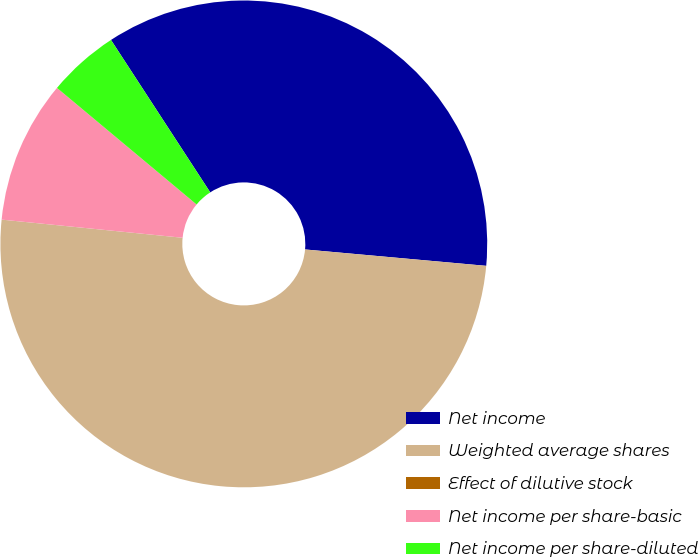Convert chart to OTSL. <chart><loc_0><loc_0><loc_500><loc_500><pie_chart><fcel>Net income<fcel>Weighted average shares<fcel>Effect of dilutive stock<fcel>Net income per share-basic<fcel>Net income per share-diluted<nl><fcel>35.62%<fcel>50.15%<fcel>0.0%<fcel>9.48%<fcel>4.74%<nl></chart> 